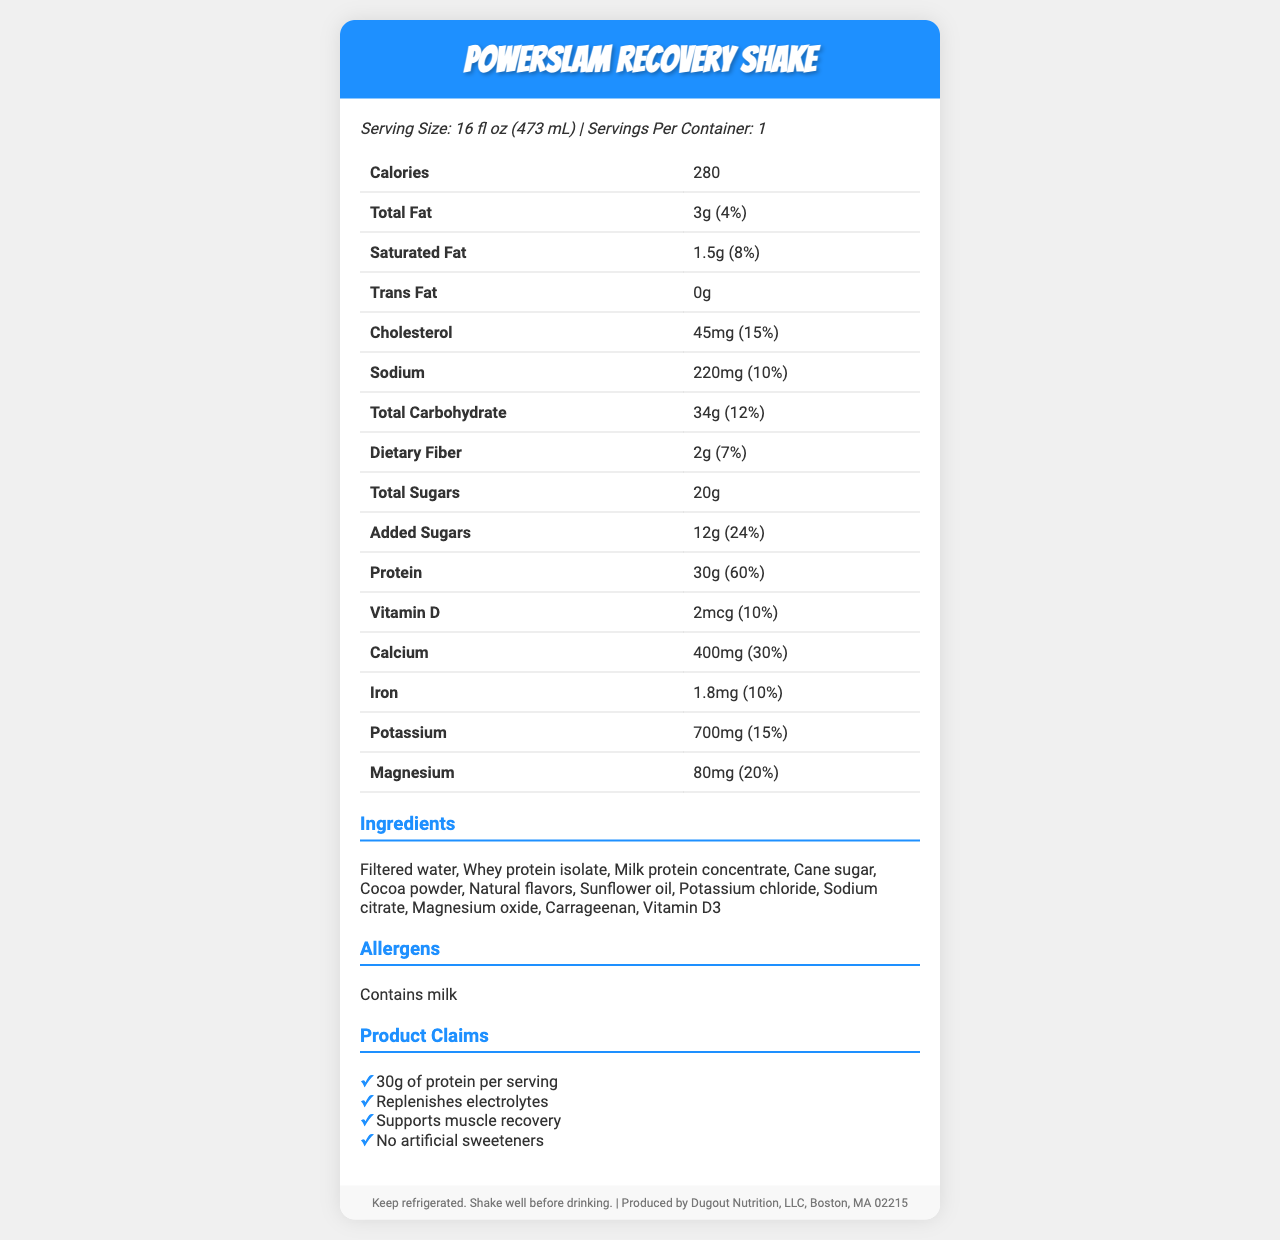How many calories are in a serving of PowerSlam Recovery Shake? The document states that there are 280 calories in one serving of the PowerSlam Recovery Shake.
Answer: 280 What is the serving size of the PowerSlam Recovery Shake? The document lists the serving size as 16 fl oz (473 mL).
Answer: 16 fl oz (473 mL) What percentage of the daily value for protein does one serving of the shake provide? The document indicates that one serving of the shake provides 60% of the daily value for protein.
Answer: 60% Name three ingredients found in the PowerSlam Recovery Shake. The ingredients section of the document lists these among other ingredients.
Answer: Filtered water, Whey protein isolate, Milk protein concentrate Are there any artificial sweeteners in the PowerSlam Recovery Shake? The document includes a claim stating "No artificial sweeteners".
Answer: No What is the total carbohydrate content per serving? The total carbohydrate content per serving listed is 34g.
Answer: 34g How much calcium does one serving of the shake contain? The document specifies that one serving contains 400mg of calcium.
Answer: 400mg Which of the following fatty acids is not present in the shake?
A. Saturated Fat
B. Trans Fat
C. Polyunsaturated Fat The document lists amounts for saturated fat (1.5g) and explicitly states that there are 0g of trans fat, but it does not mention polyunsaturated fat.
Answer: C. Polyunsaturated Fat What daily percentage of Vitamin D does the shake provide? The shake provides 2 mcg of Vitamin D, which is 10% of the daily value.
Answer: 10% What is the primary function of this recovery shake as listed under product claims? A. Helps in weight loss B. Supports muscle recovery C. Improves digestion The document lists "Supports muscle recovery" as one of the product claims.
Answer: B. Supports muscle recovery Does the PowerSlam Recovery Shake contain any allergens? The document states that the shake contains milk as an allergen.
Answer: Yes Can we determine the cost of the PowerSlam Recovery Shake from this document? The document does not provide any information regarding the cost of the shake.
Answer: Cannot be determined Summarize the key information provided in the document. The document provides detailed nutritional information about the PowerSlam Recovery Shake, including serving size, ingredient list, nutritional values, storage instructions, and manufacturer information, highlighting its benefits and allergen content.
Answer: The PowerSlam Recovery Shake is a post-game recovery drink that contains 280 calories per serving. It has 30g of protein, replenishes electrolytes, and supports muscle recovery. The shake also includes essential vitamins and minerals such as Vitamin D, calcium, and potassium. It contains no artificial sweeteners and is made with ingredients like whey protein isolate and milk protein concentrate. The shake should be kept refrigerated and shook well before drinking. It contains milk allergens and is produced by Dugout Nutrition, LLC in Boston, MA. Does the shake include added sugars? The document states that added sugars are present, amounting to 12g (24% daily value).
Answer: Yes 